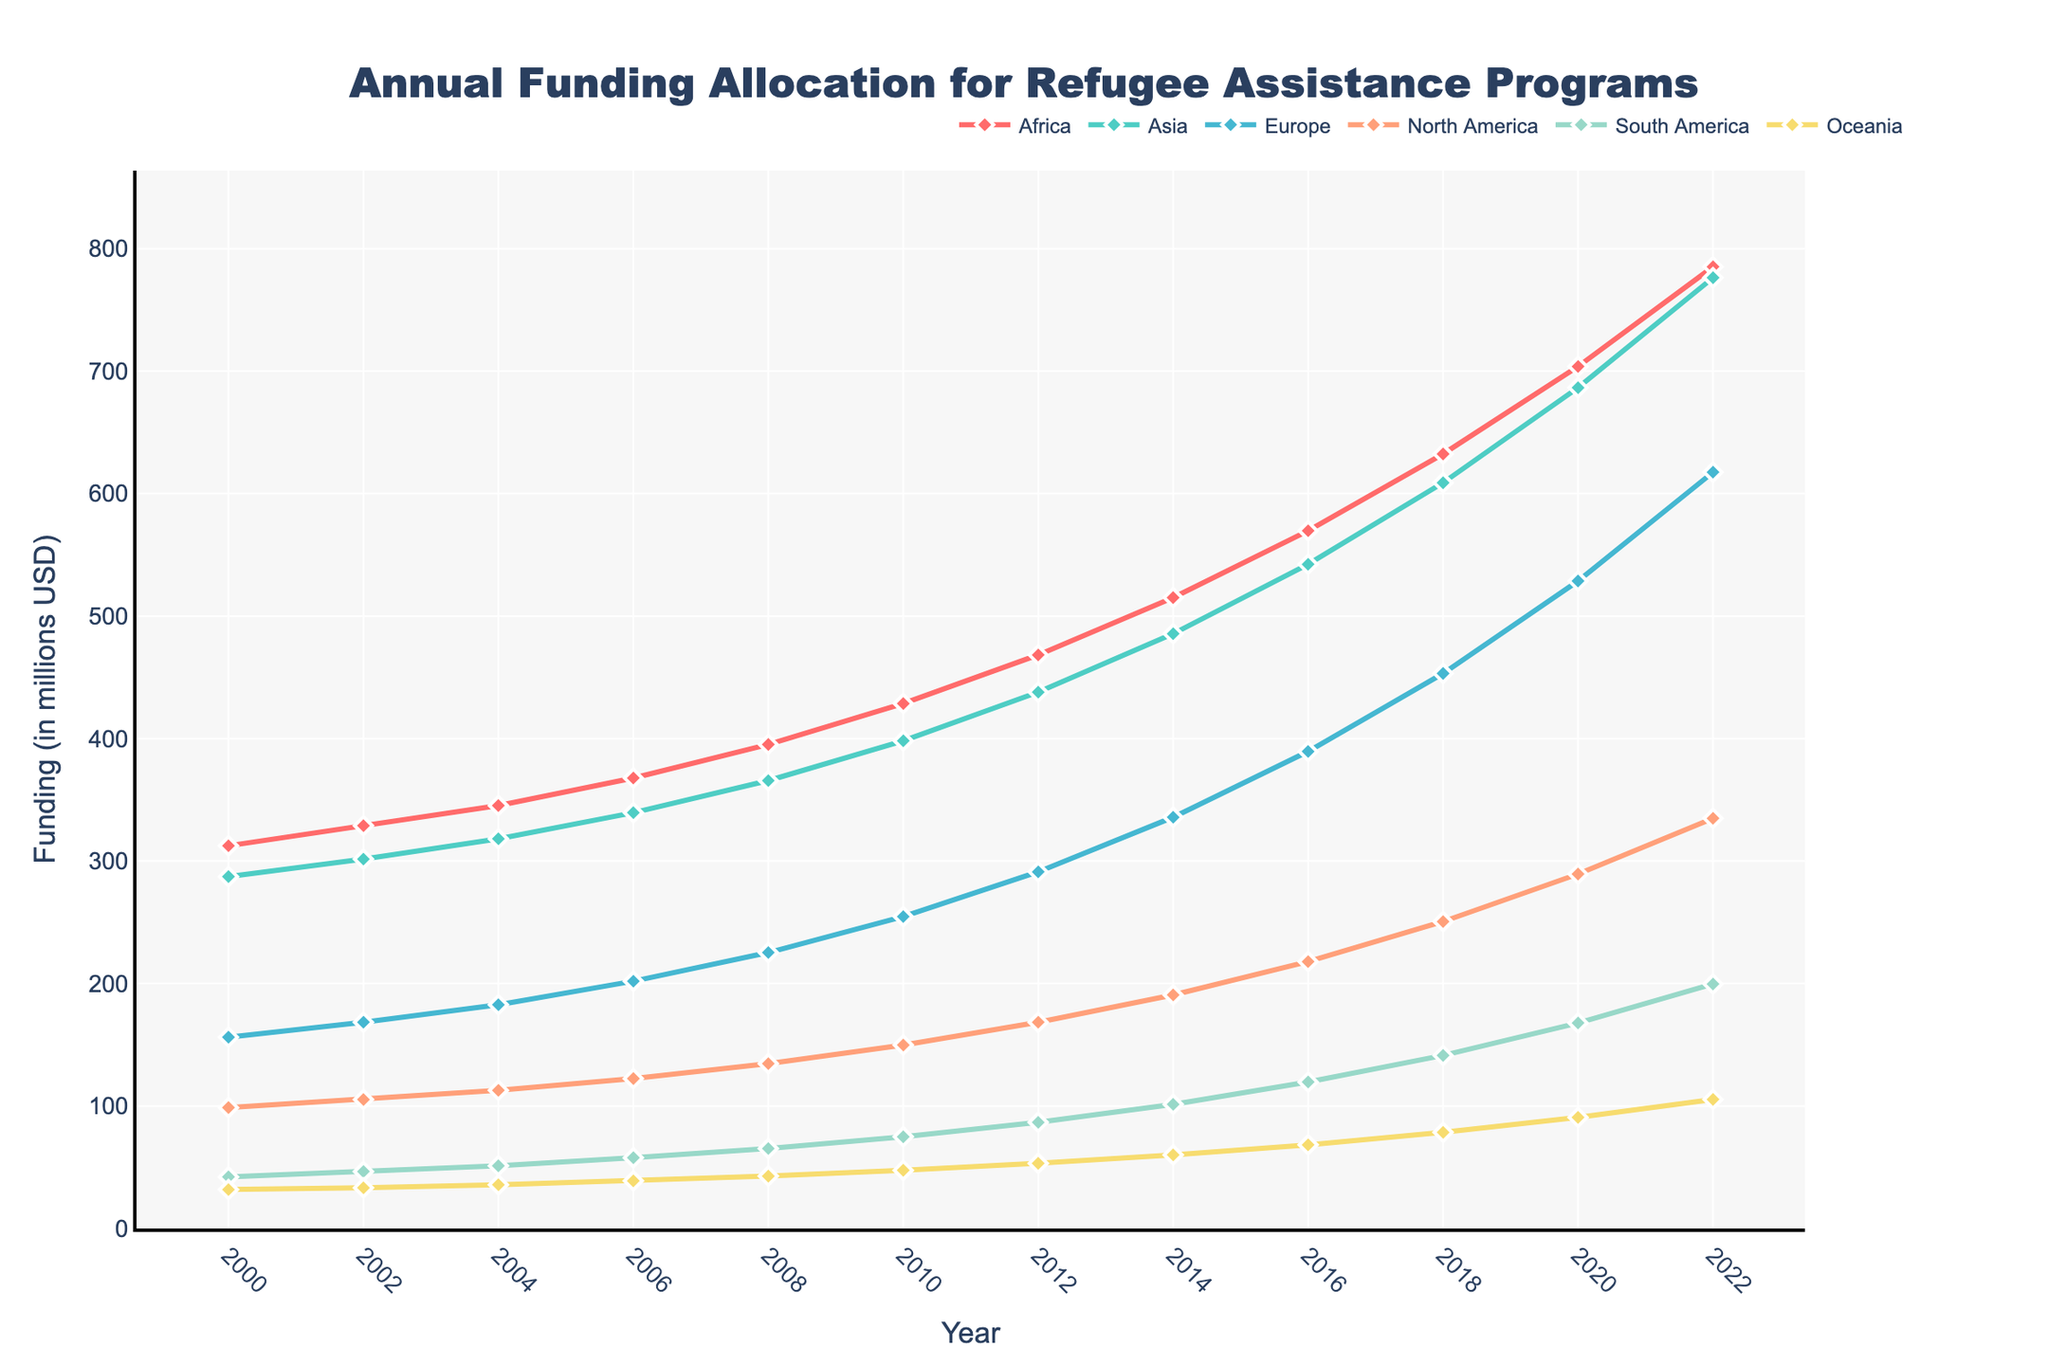What is the trend in funding allocation for Africa from 2000 to 2022? The trend can be observed by looking at how the funding allocation for Africa changes over the years from 2000 to 2022. Starting from $312.5 million in 2000, the funding increases steadily over the years and reaches $785.2 million in 2022. This shows a generally upward trend.
Answer: Increasing trend Which continent received the highest funding in 2022? To determine which continent received the highest funding in 2022, observe the y-values (funding amounts) for each continent in the year 2022 on the x-axis. The highest funding amount is $785.2 million for Africa.
Answer: Africa By how much did the funding for Europe increase from 2000 to 2022? To find the increase in funding for Europe, subtract the funding amount in 2000 from the funding amount in 2022. The funding in 2000 was $156.2 million and in 2022 it was $617.5 million. Thus, the increase is $617.5 - $156.2 = $461.3 million.
Answer: $461.3 million Compare the funding for Asia and North America in 2018. Which one had more, and by how much? Look at the funding amounts for Asia and North America for the year 2018. For Asia, it was $608.9 million, and for North America, it was $250.6 million. Comparing these, Asia had more funding by $608.9 - $250.6 = $358.3 million.
Answer: Asia by $358.3 million What is the average funding allocation for Oceania over the entire period from 2000 to 2022? To find the average funding for Oceania, sum the yearly funding amounts and divide by the number of years. The sum is $31.8 + $33.2 + $35.7 + $38.9 + $42.8 + $47.5 + $53.2 + $60.1 + $68.3 + $78.5 + $90.7 + $105.4 = $686.1 million. There are 12 years, so the average is $686.1 / 12 ≈ $57.18 million per year.
Answer: $57.18 million per year Identify any year when the funding for South America was equal to or greater than $100 million. Review the y-values for South America across the years. The funding for South America reached $101.4 million in 2014, which is the first year it exceeded $100 million.
Answer: 2014 How does the funding growth rate for Africa compare to that of Europe from 2000 to 2022? To compare the growth rates, calculate the percentage increase for both continents. For Africa: (($785.2 - $312.5) / $312.5) * 100 = 151.3%. For Europe: (($617.5 - $156.2) / $156.2) * 100 = 295.3%. Therefore, Europe's funding growth rate is higher.
Answer: Europe's growth rate is higher What was the funding allocation for North America in 2006, and how does it compare to South America's funding in the same year? Check the funding values for both continents in 2006. North America had $122.4 million, and South America had $57.8 million. North America's funding was higher than South America's.
Answer: North America higher: $122.4 million vs. $57.8 million What colors represent Asia and North America in the plot? According to the described color palette, Asia is represented by a teal color, and North America by a light orange color.
Answer: Teal for Asia, Light Orange for North America 